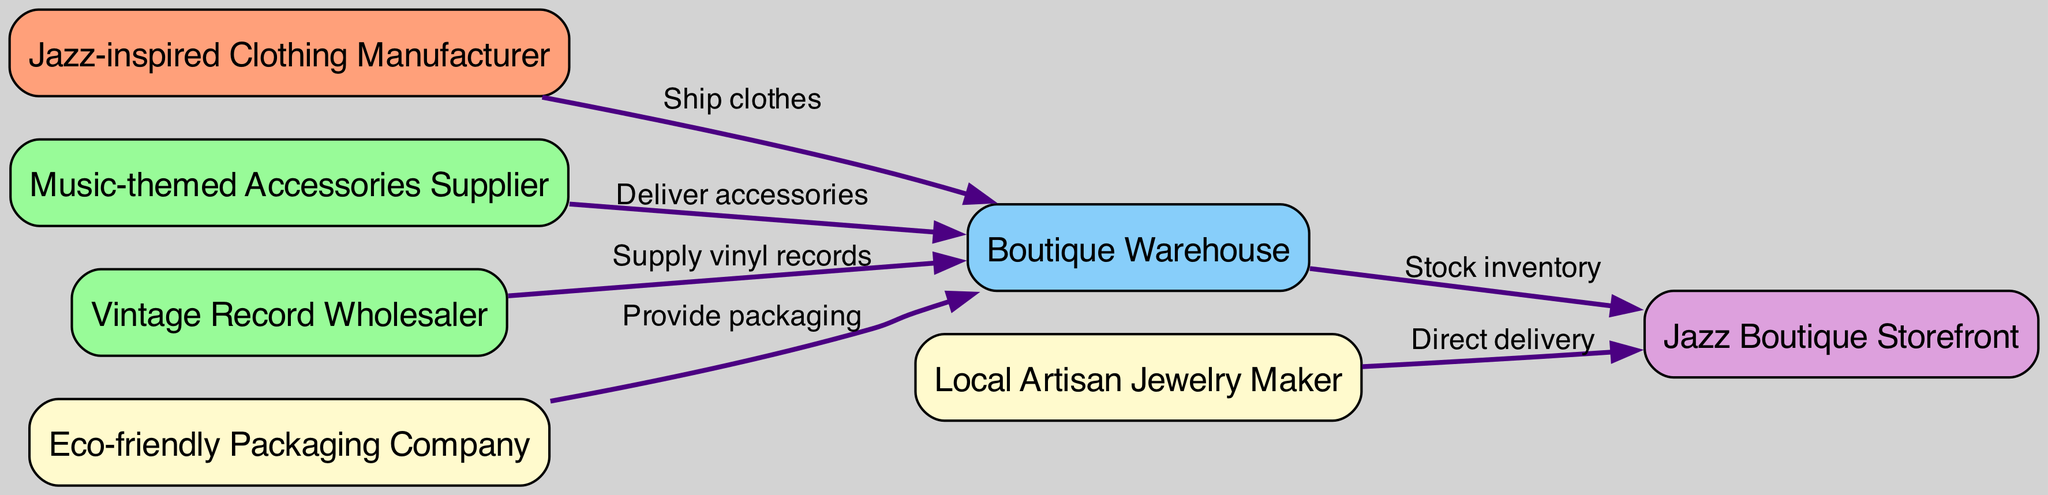What is the total number of nodes in the diagram? There are seven nodes in the diagram: "Jazz-inspired Clothing Manufacturer," "Music-themed Accessories Supplier," "Vintage Record Wholesaler," "Eco-friendly Packaging Company," "Local Artisan Jewelry Maker," "Boutique Warehouse," and "Jazz Boutique Storefront." Counting these, we confirm that the total is seven.
Answer: 7 Which node delivers accessories to the boutique warehouse? The node that delivers accessories to the boutique warehouse is the "Music-themed Accessories Supplier" as indicated by the directed edge labeled "Deliver accessories" pointing toward "Boutique Warehouse."
Answer: Music-themed Accessories Supplier How many unique suppliers or manufacturers are involved in the supply chain? The supply chain includes three unique manufacturers/suppliers: "Jazz-inspired Clothing Manufacturer," "Music-themed Accessories Supplier," and "Vintage Record Wholesaler" along with one more source of supply, which is the "Local Artisan Jewelry Maker," totaling four.
Answer: 4 What is the final destination for inventory according to the diagram? The final destination of inventory in the diagram is the "Jazz Boutique Storefront" as represented by the directed edge labeled "Stock inventory," which leads to this node from "Boutique Warehouse."
Answer: Jazz Boutique Storefront Which node supplies vinyl records, and what is the next step after that? The "Vintage Record Wholesaler" supplies vinyl records, and after supplying them, the next step is that the items go to the "Boutique Warehouse," where they will be handled and eventually stocked for sale.
Answer: Boutique Warehouse Which node provides packaging for the boutique warehouse? The node that provides packaging to the boutique warehouse is the "Eco-friendly Packaging Company" with a directed edge labeled "Provide packaging" flowing into "Boutique Warehouse."
Answer: Eco-friendly Packaging Company What is the type of relationship between the boutique warehouse and the jazz boutique storefront? The relationship between the boutique warehouse and the jazz boutique storefront is described as "Stock inventory," which indicates that the boutique warehouse stocks the inventory for the storefront, thus managing supply to the final sales point.
Answer: Stock inventory What is unique about the delivery from the local artisan jewelry maker? The delivery from the "Local Artisan Jewelry Maker" is unique because it is a "Direct delivery" to the "Jazz Boutique Storefront," implying that there is no intermediary step like a warehouse, distinguishing it from other supplies.
Answer: Direct delivery 